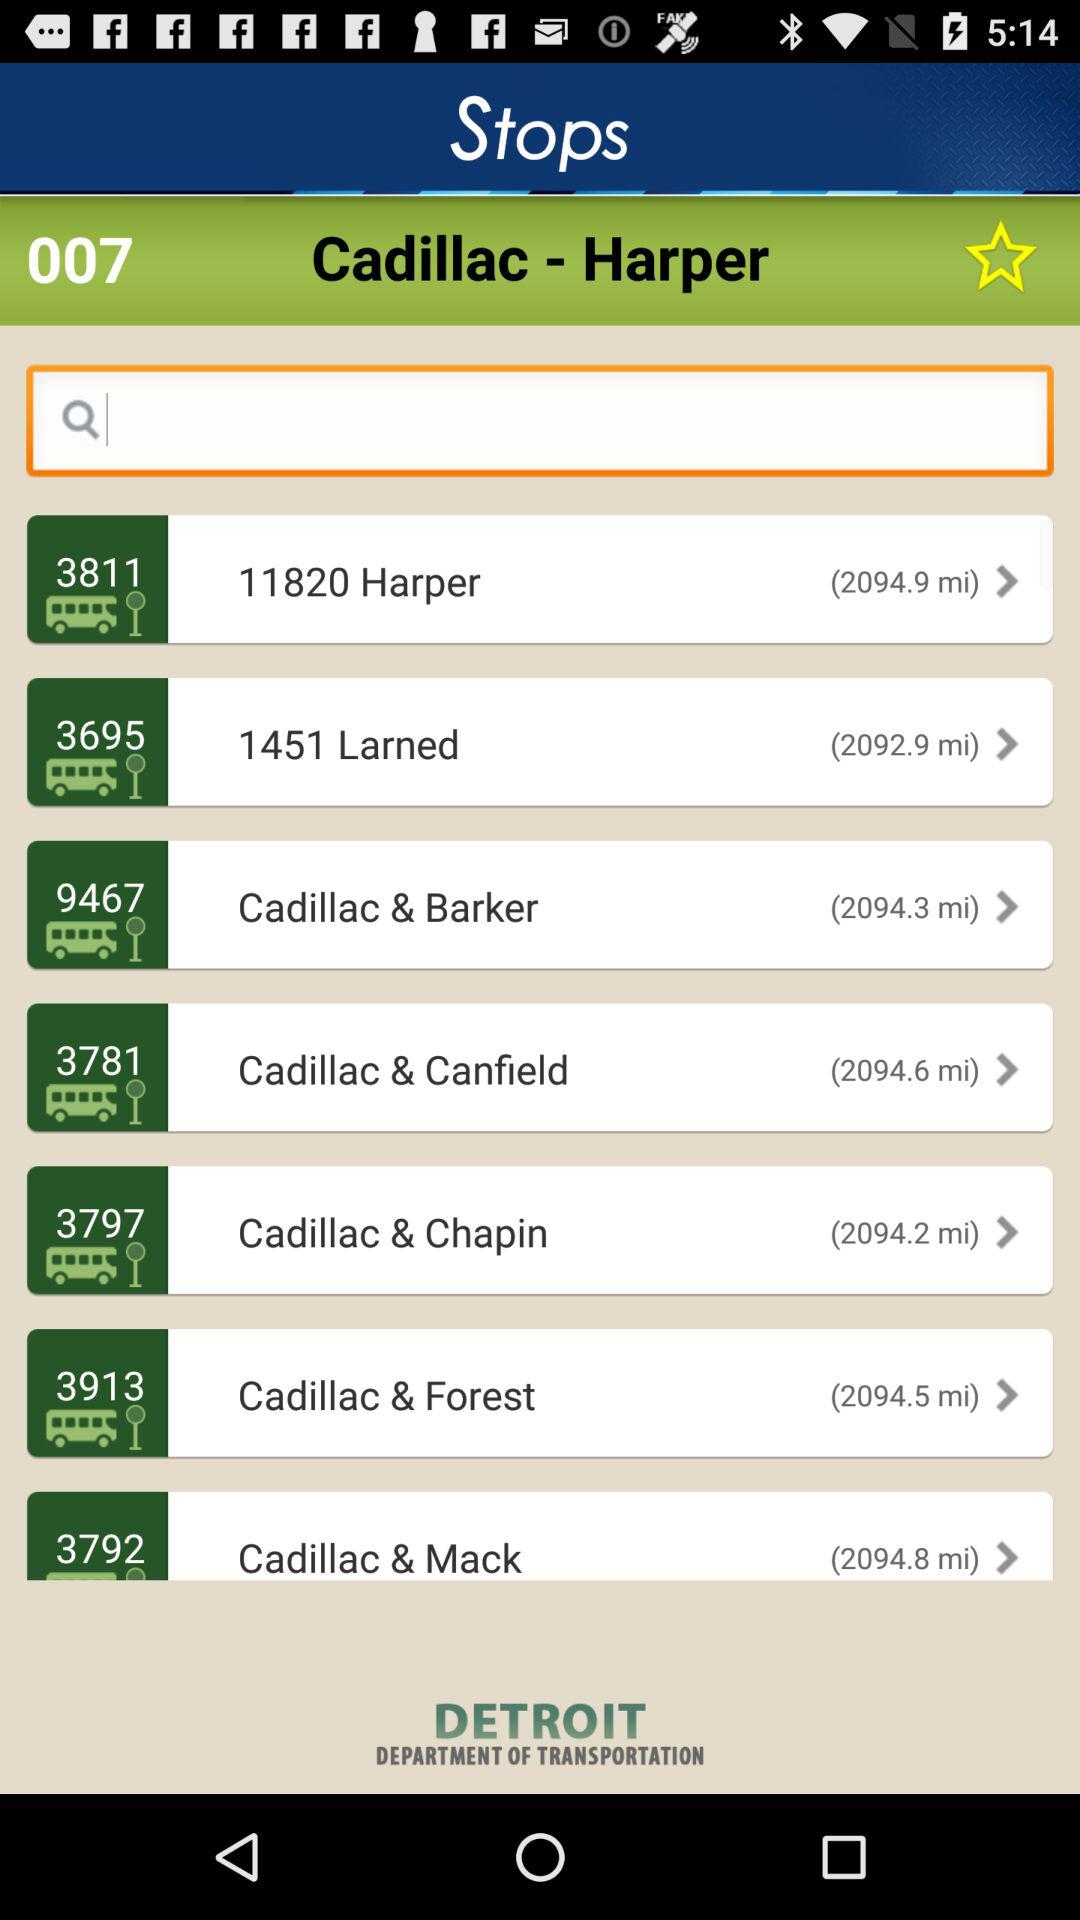What is the bus number shown for the stop 1451 Larned?
Answer the question using a single word or phrase. It is 3695. 